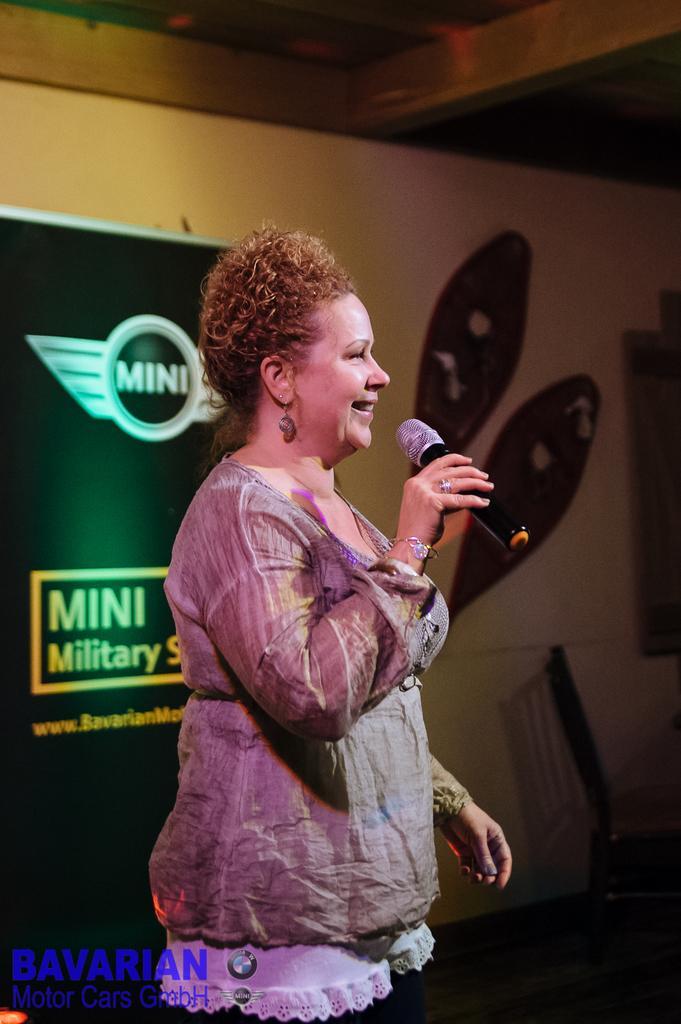In one or two sentences, can you explain what this image depicts? In this picture there is a woman holding a mic and smiling. In the background there is a poster and a wall here. 